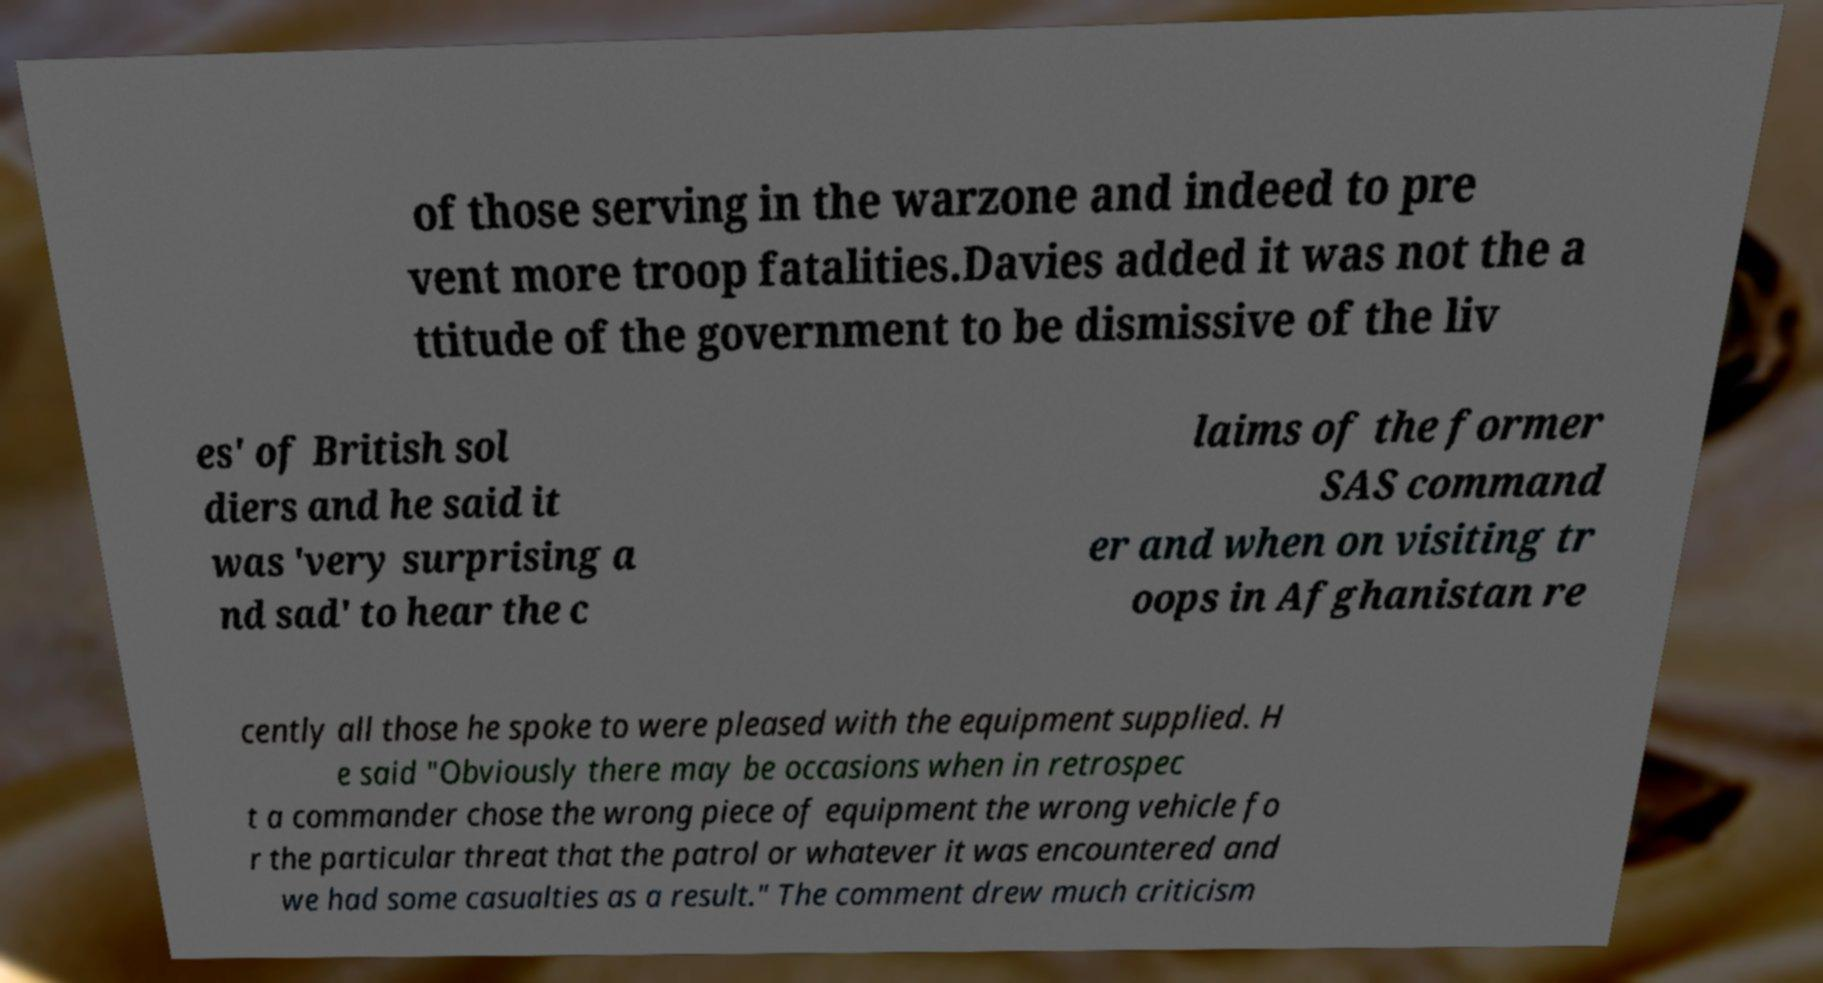For documentation purposes, I need the text within this image transcribed. Could you provide that? of those serving in the warzone and indeed to pre vent more troop fatalities.Davies added it was not the a ttitude of the government to be dismissive of the liv es' of British sol diers and he said it was 'very surprising a nd sad' to hear the c laims of the former SAS command er and when on visiting tr oops in Afghanistan re cently all those he spoke to were pleased with the equipment supplied. H e said "Obviously there may be occasions when in retrospec t a commander chose the wrong piece of equipment the wrong vehicle fo r the particular threat that the patrol or whatever it was encountered and we had some casualties as a result." The comment drew much criticism 